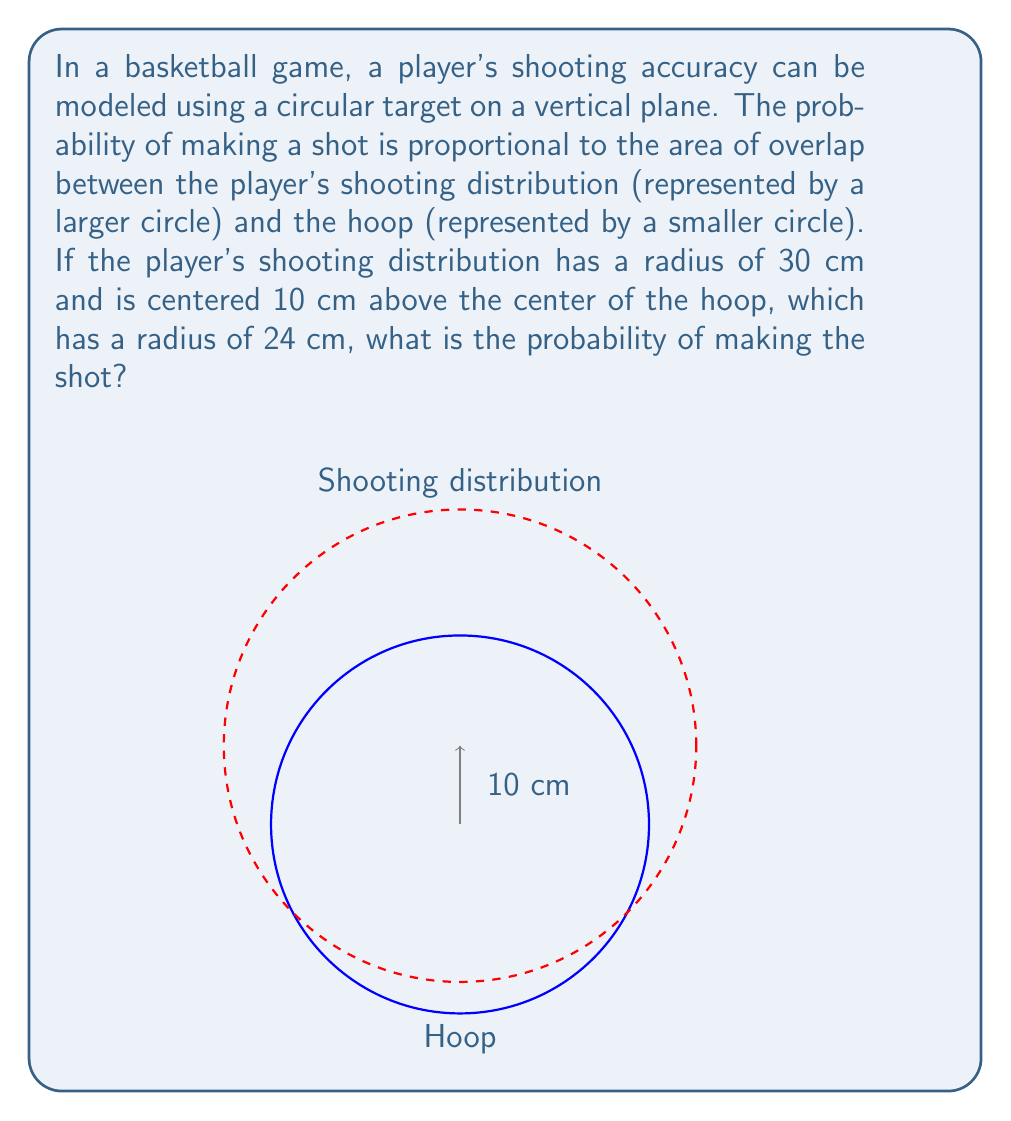What is the answer to this math problem? To solve this problem, we need to calculate the area of overlap between two circles using geometric probability. Let's approach this step-by-step:

1) First, we need to find the distance between the centers of the two circles:
   $d = 10$ cm

2) The radii of the circles are:
   $R = 30$ cm (shooting distribution)
   $r = 24$ cm (hoop)

3) To find the area of overlap, we can use the formula for the area of intersection of two circles:

   $A = r^2 \arccos(\frac{d^2 + r^2 - R^2}{2dr}) + R^2 \arccos(\frac{d^2 + R^2 - r^2}{2dR}) - \frac{1}{2}\sqrt{(-d+r+R)(d+r-R)(d-r+R)(d+r+R)}$

4) Substituting our values:

   $A = 24^2 \arccos(\frac{10^2 + 24^2 - 30^2}{2 \cdot 10 \cdot 24}) + 30^2 \arccos(\frac{10^2 + 30^2 - 24^2}{2 \cdot 10 \cdot 30}) - \frac{1}{2}\sqrt{(-10+24+30)(10+24-30)(10-24+30)(10+24+30)}$

5) Calculating this (you would use a calculator):

   $A \approx 1591.55$ cm²

6) The total area of the shooting distribution is:
   $A_{total} = \pi R^2 = \pi \cdot 30^2 \approx 2827.43$ cm²

7) The probability is the ratio of the overlap area to the total area:

   $P = \frac{A}{A_{total}} = \frac{1591.55}{2827.43} \approx 0.5629$

Therefore, the probability of making the shot is approximately 0.5629 or 56.29%.
Answer: $0.5629$ or $56.29\%$ 